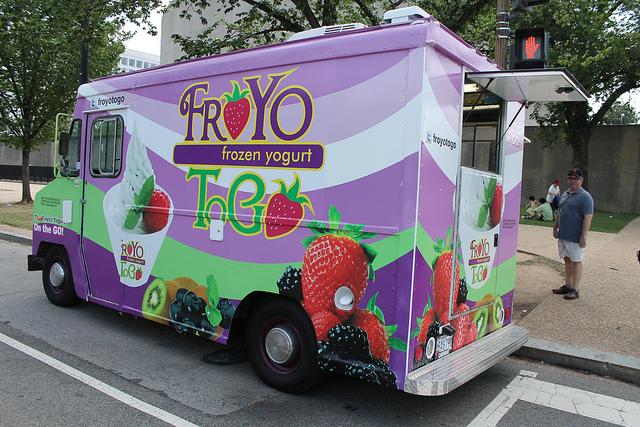What fruit is seen in the cup on the truck? Please explain your reasoning. raspberry. A red berry is seen in a cup. raspberries are red. 